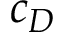Convert formula to latex. <formula><loc_0><loc_0><loc_500><loc_500>c _ { D }</formula> 